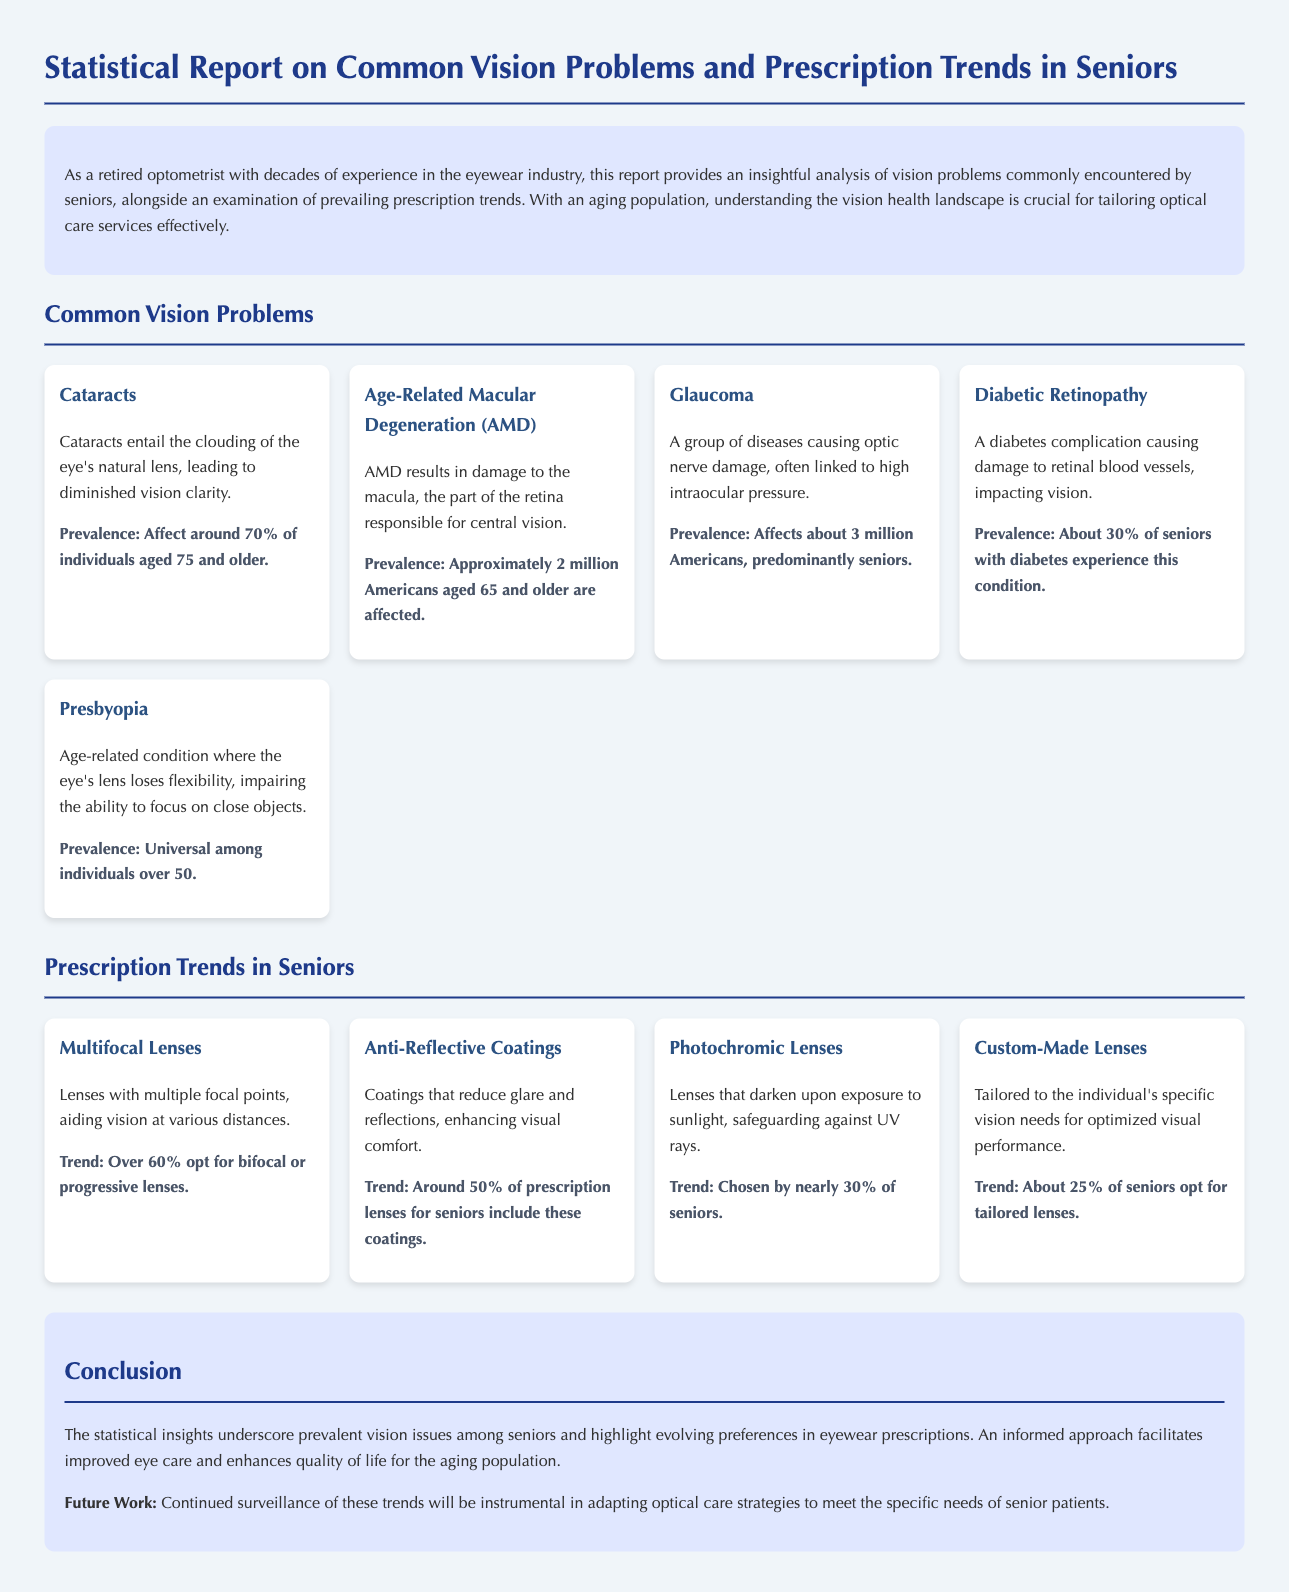What is the percentage of seniors affected by cataracts? The document states that around 70% of individuals aged 75 and older are affected by cataracts.
Answer: 70% How many Americans aged 65 and older are affected by Age-Related Macular Degeneration (AMD)? The document mentions that approximately 2 million Americans aged 65 and older are affected by AMD.
Answer: 2 million What is the prevalence rate of glaucoma among seniors? The document indicates that glaucoma affects about 3 million Americans, predominantly seniors.
Answer: 3 million What percentage of seniors opt for bifocal or progressive lenses? According to the document, over 60% opt for bifocal or progressive lenses.
Answer: Over 60% What trend percentage of seniors includes anti-reflective coatings in their prescription lenses? The document states that around 50% of prescription lenses for seniors include anti-reflective coatings.
Answer: Around 50% What visual condition is universal among individuals over 50? The report states that presbyopia is universal among individuals over 50.
Answer: Presbyopia What type of lenses do nearly 30% of seniors choose? The document states that nearly 30% of seniors opt for photochromic lenses.
Answer: Photochromic lenses What is the overall aim of the report? The conclusion section mentions that the report aims to facilitate improved eye care and enhance the quality of life for the aging population.
Answer: Improved eye care What future work is suggested in the report? The document indicates that continued surveillance of trends will be instrumental in adapting optical care strategies.
Answer: Continued surveillance of trends 